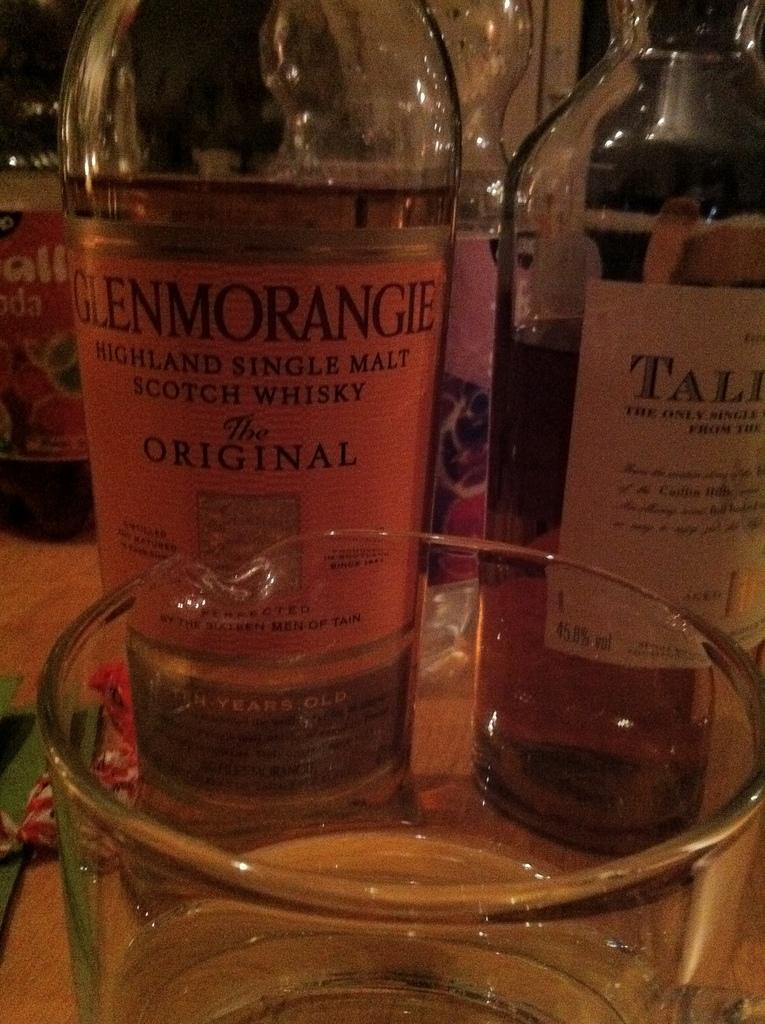<image>
Relay a brief, clear account of the picture shown. A bottle of "GLENMORANGIE" Whisky is on the table. 